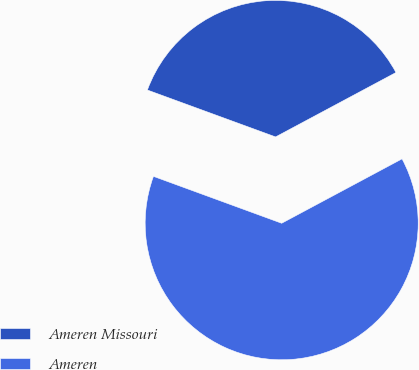Convert chart. <chart><loc_0><loc_0><loc_500><loc_500><pie_chart><fcel>Ameren Missouri<fcel>Ameren<nl><fcel>36.6%<fcel>63.4%<nl></chart> 